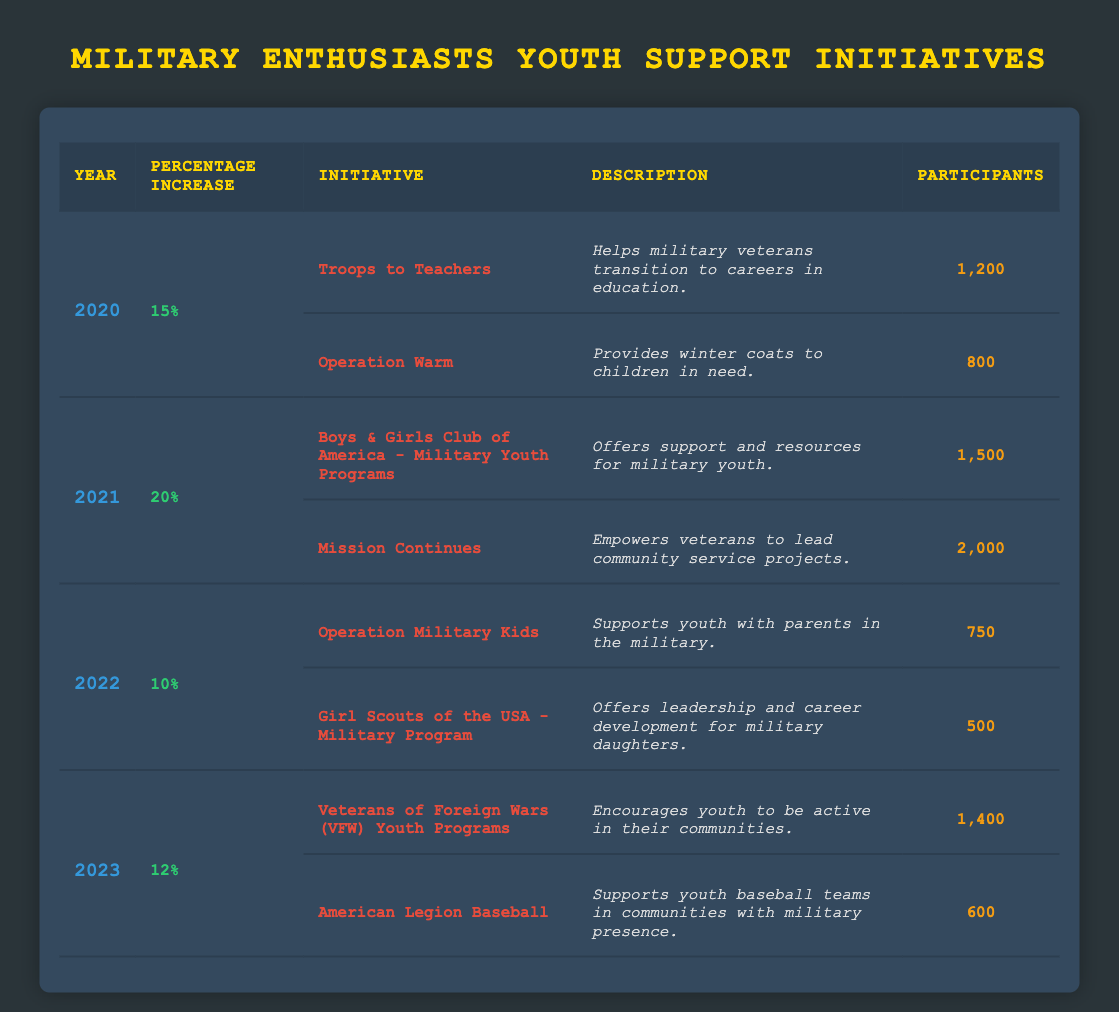What was the percentage increase in volunteerism from 2020 to 2021? The percentage increase in 2020 was 15% and in 2021 it was 20%. The difference between the two years is 20% - 15% = 5%.
Answer: 5% Which initiative had the highest number of participants in 2021? In 2021, the initiatives were the Boys & Girls Club of America with 1500 participants and Mission Continues with 2000 participants. Mission Continues had the highest number of participants.
Answer: Mission Continues Did the percentage increase in volunteerism decrease from 2021 to 2022? The percentage increase in 2021 was 20% and in 2022 it was 10%. Since 10% is less than 20%, the percentage increase did decrease.
Answer: Yes What is the total number of participants across all initiatives in 2023? The initiatives in 2023 had 1400 participants in VFW Youth Programs and 600 in American Legion Baseball. Adding these together gives 1400 + 600 = 2000 participants in total for 2023.
Answer: 2000 Is Operation Warm active in the year 2022? According to the table, Operation Warm is listed under 2020, but there are no entries for it in 2022. Therefore, Operation Warm is not active in 2022.
Answer: No Which year saw the most initiatives with over 1000 participants? In 2021, there were two initiatives with over 1000 participants: Boys & Girls Club (1500) and Mission Continues (2000). In other years, there were fewer initiatives with participants above 1000. Thus, 2021 had the most.
Answer: 2021 How much did the percentage increase of volunteerism drop from 2021 to 2022? The percentage increase in 2021 was 20% and it dropped to 10% in 2022. The difference is 20% - 10% = 10%, indicating a drop of 10%.
Answer: 10% What description is associated with the initiative "Troops to Teachers"? The description provided for Troops to Teachers is that it helps military veterans transition to careers in education.
Answer: Helps military veterans transition to careers in education 